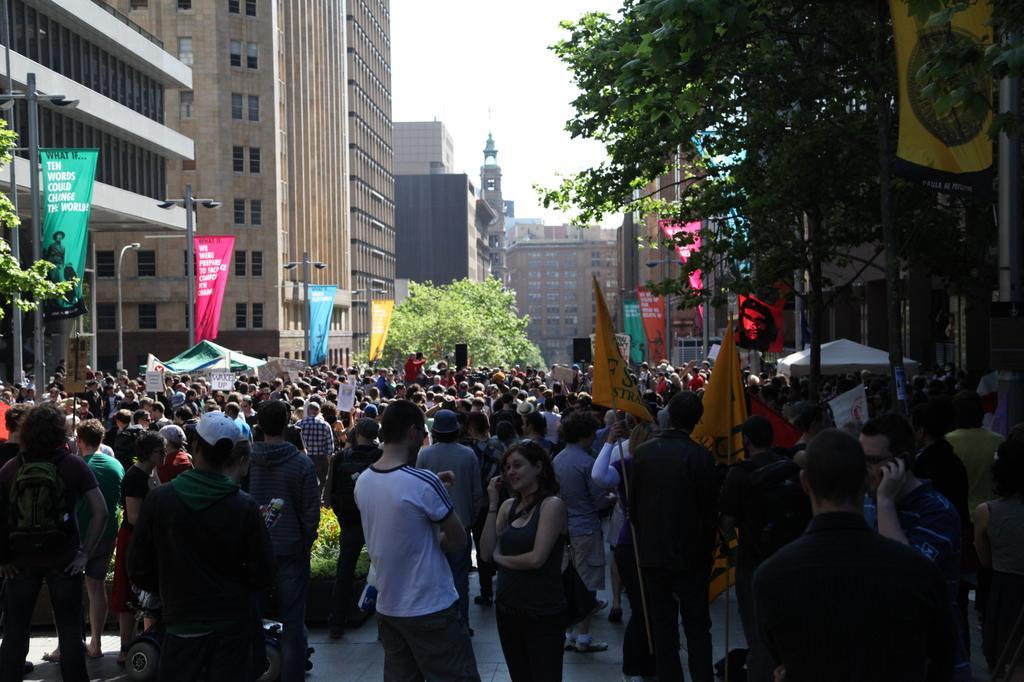Please provide a concise description of this image. In this image there are a group of people who are standing and some of them are holding some flags, and on the right and left side there are some trees, buildings and some boards. And at the top of the image there is sky, and also we could see some poles. 